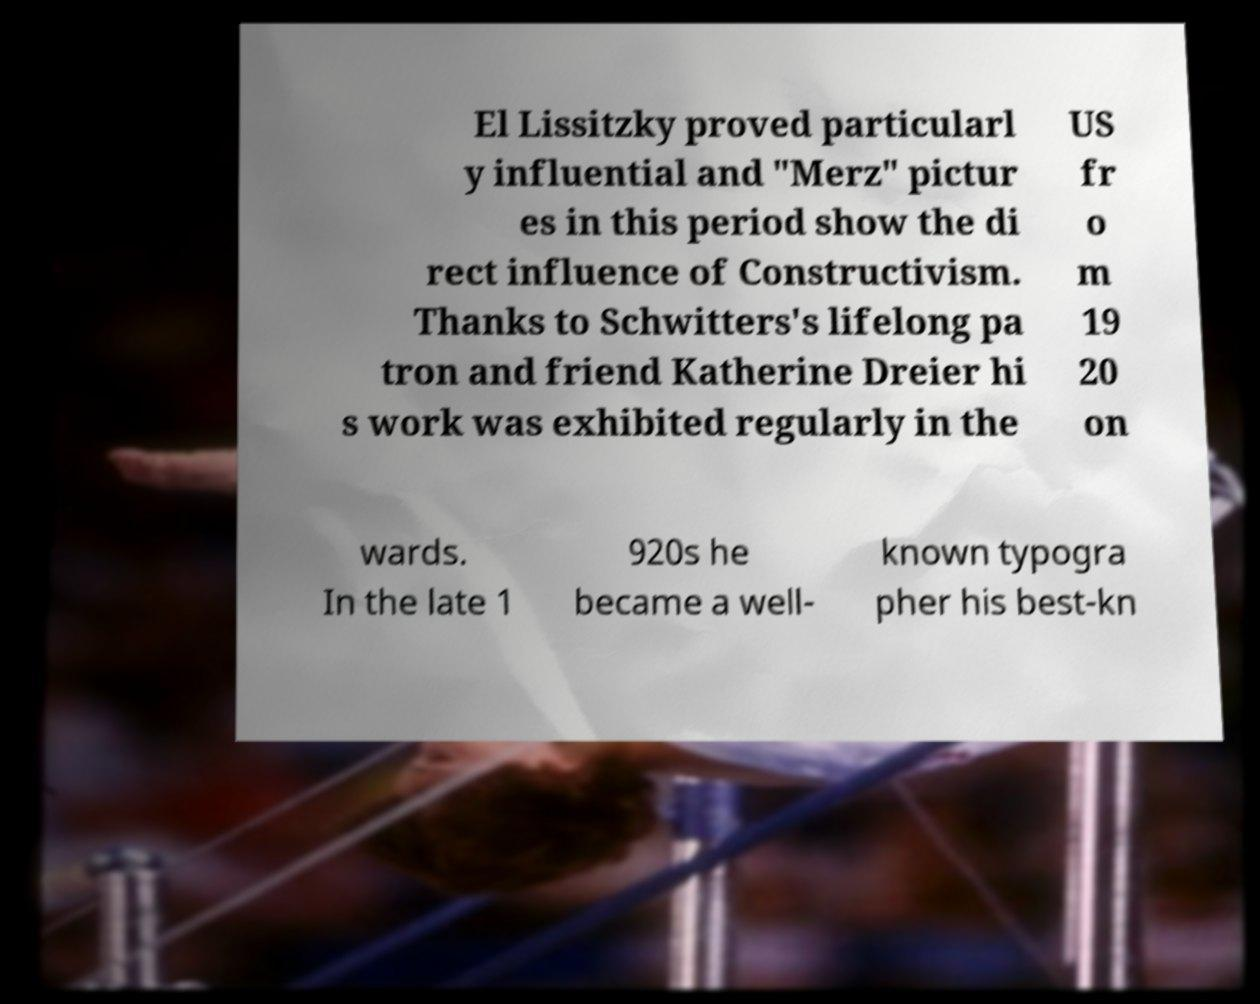What messages or text are displayed in this image? I need them in a readable, typed format. El Lissitzky proved particularl y influential and "Merz" pictur es in this period show the di rect influence of Constructivism. Thanks to Schwitters's lifelong pa tron and friend Katherine Dreier hi s work was exhibited regularly in the US fr o m 19 20 on wards. In the late 1 920s he became a well- known typogra pher his best-kn 